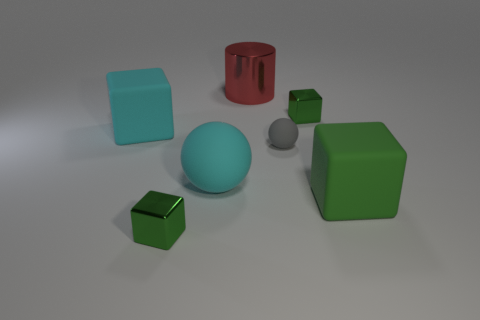What number of tiny green metallic things are both right of the big metal cylinder and to the left of the big red cylinder?
Your answer should be compact. 0. What number of other objects are the same size as the red shiny thing?
Ensure brevity in your answer.  3. Are there the same number of small gray objects behind the tiny gray object and brown rubber cubes?
Your answer should be compact. Yes. Do the tiny cube in front of the large cyan matte block and the rubber thing on the right side of the small rubber sphere have the same color?
Provide a short and direct response. Yes. What is the object that is in front of the big matte sphere and left of the red cylinder made of?
Keep it short and to the point. Metal. The big rubber ball has what color?
Ensure brevity in your answer.  Cyan. How many other objects are there of the same shape as the large green object?
Provide a succinct answer. 3. Are there an equal number of small green shiny blocks that are on the right side of the big green object and small green shiny cubes that are in front of the big cyan rubber sphere?
Your response must be concise. No. What is the material of the gray thing?
Keep it short and to the point. Rubber. There is a green cube that is on the left side of the large cylinder; what is its material?
Offer a terse response. Metal. 